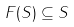Convert formula to latex. <formula><loc_0><loc_0><loc_500><loc_500>F ( S ) \subseteq S</formula> 